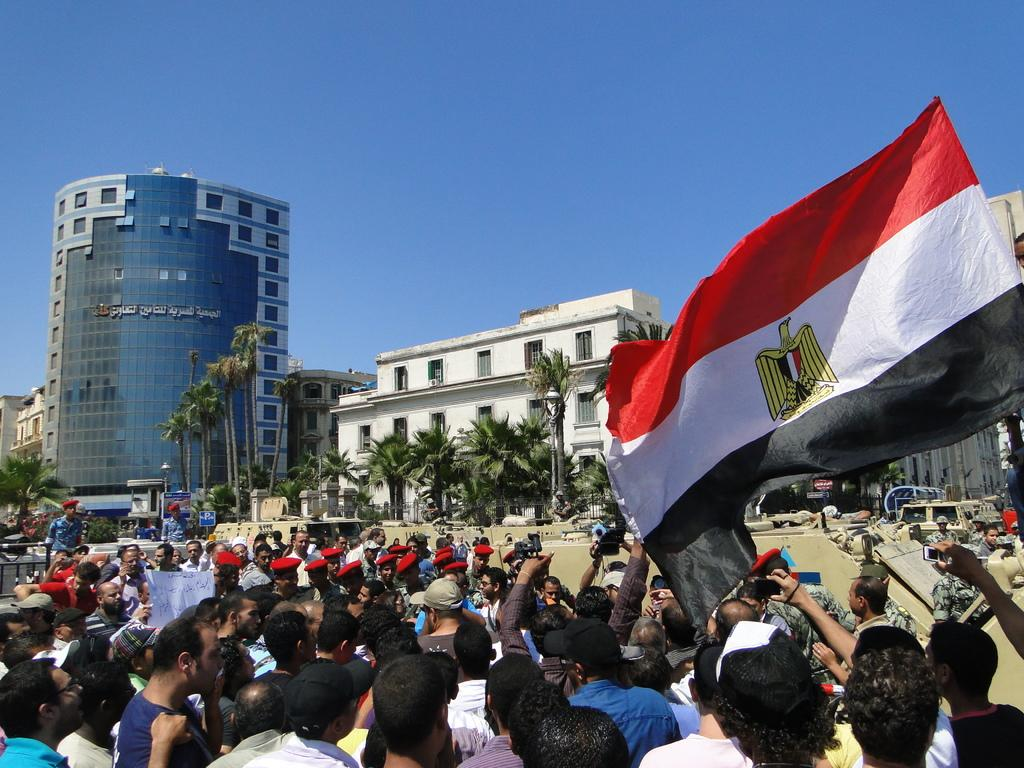What are the people in the image doing? There are people protesting in the image. What can be seen on the right side of the image? There is a flag on the right side of the image. What is visible elements are in the background of the image? There are trees and buildings in the background of the image. Can you tell me what type of receipt is being held by the protesters in the image? There is no receipt visible in the image; the focus is on the people protesting and the flag on the right side. 